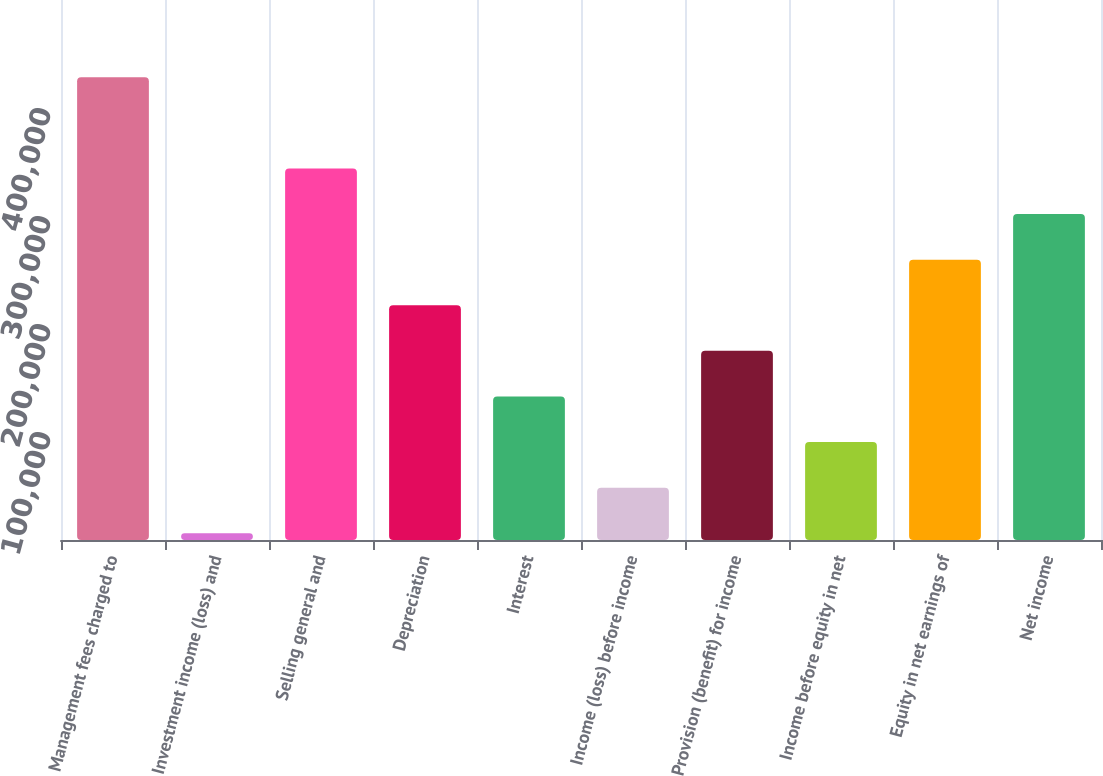Convert chart. <chart><loc_0><loc_0><loc_500><loc_500><bar_chart><fcel>Management fees charged to<fcel>Investment income (loss) and<fcel>Selling general and<fcel>Depreciation<fcel>Interest<fcel>Income (loss) before income<fcel>Provision (benefit) for income<fcel>Income before equity in net<fcel>Equity in net earnings of<fcel>Net income<nl><fcel>428426<fcel>6279<fcel>343997<fcel>217352<fcel>132923<fcel>48493.7<fcel>175138<fcel>90708.4<fcel>259567<fcel>301782<nl></chart> 